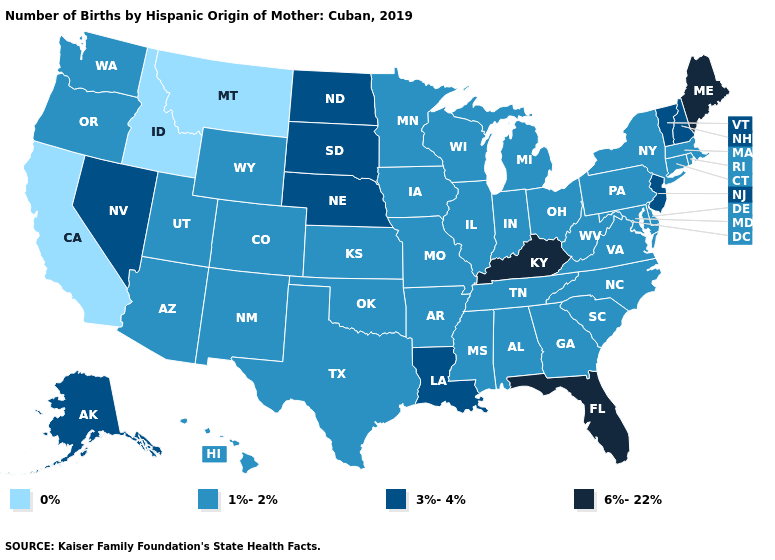Name the states that have a value in the range 1%-2%?
Write a very short answer. Alabama, Arizona, Arkansas, Colorado, Connecticut, Delaware, Georgia, Hawaii, Illinois, Indiana, Iowa, Kansas, Maryland, Massachusetts, Michigan, Minnesota, Mississippi, Missouri, New Mexico, New York, North Carolina, Ohio, Oklahoma, Oregon, Pennsylvania, Rhode Island, South Carolina, Tennessee, Texas, Utah, Virginia, Washington, West Virginia, Wisconsin, Wyoming. Which states hav the highest value in the South?
Give a very brief answer. Florida, Kentucky. What is the value of Iowa?
Keep it brief. 1%-2%. What is the lowest value in the Northeast?
Give a very brief answer. 1%-2%. Name the states that have a value in the range 3%-4%?
Keep it brief. Alaska, Louisiana, Nebraska, Nevada, New Hampshire, New Jersey, North Dakota, South Dakota, Vermont. Does Maine have the highest value in the USA?
Give a very brief answer. Yes. What is the value of Alaska?
Write a very short answer. 3%-4%. How many symbols are there in the legend?
Short answer required. 4. What is the highest value in the West ?
Be succinct. 3%-4%. Which states hav the highest value in the South?
Keep it brief. Florida, Kentucky. Does New Hampshire have the same value as Virginia?
Be succinct. No. Does Maine have the highest value in the Northeast?
Be succinct. Yes. Does Virginia have the lowest value in the South?
Concise answer only. Yes. Which states have the highest value in the USA?
Short answer required. Florida, Kentucky, Maine. Name the states that have a value in the range 1%-2%?
Short answer required. Alabama, Arizona, Arkansas, Colorado, Connecticut, Delaware, Georgia, Hawaii, Illinois, Indiana, Iowa, Kansas, Maryland, Massachusetts, Michigan, Minnesota, Mississippi, Missouri, New Mexico, New York, North Carolina, Ohio, Oklahoma, Oregon, Pennsylvania, Rhode Island, South Carolina, Tennessee, Texas, Utah, Virginia, Washington, West Virginia, Wisconsin, Wyoming. 